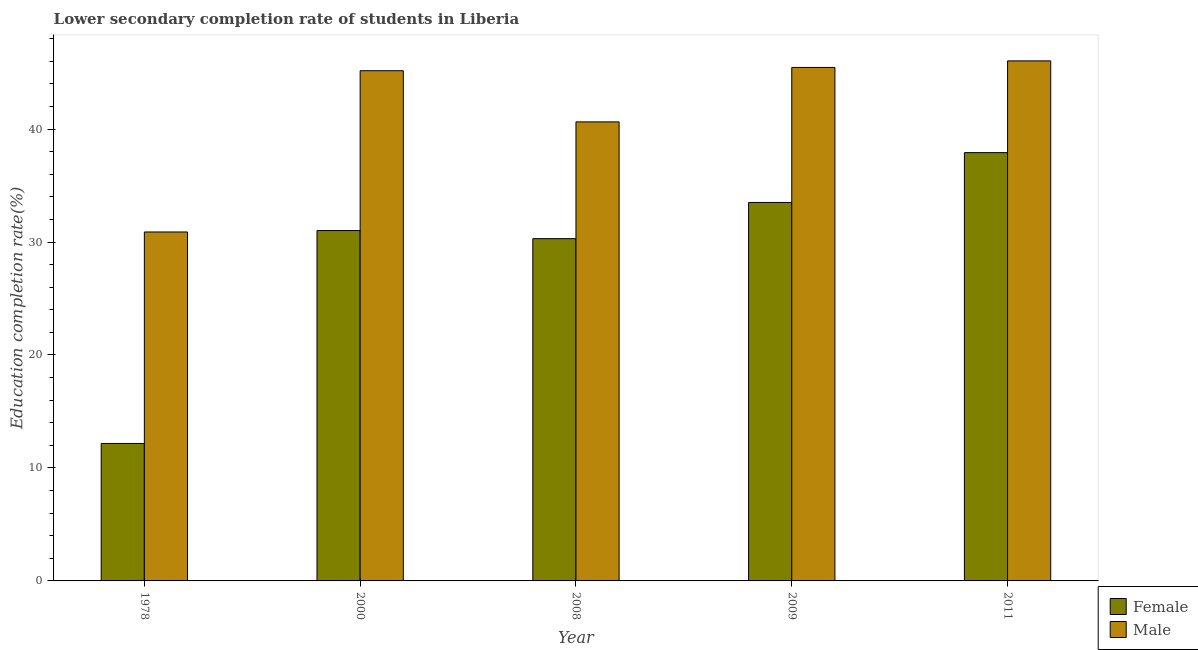How many different coloured bars are there?
Offer a terse response. 2. How many groups of bars are there?
Offer a terse response. 5. Are the number of bars per tick equal to the number of legend labels?
Ensure brevity in your answer.  Yes. How many bars are there on the 3rd tick from the left?
Provide a short and direct response. 2. How many bars are there on the 4th tick from the right?
Your answer should be very brief. 2. What is the label of the 4th group of bars from the left?
Offer a terse response. 2009. In how many cases, is the number of bars for a given year not equal to the number of legend labels?
Your answer should be very brief. 0. What is the education completion rate of male students in 2008?
Keep it short and to the point. 40.64. Across all years, what is the maximum education completion rate of male students?
Your answer should be very brief. 46.04. Across all years, what is the minimum education completion rate of female students?
Make the answer very short. 12.17. In which year was the education completion rate of male students maximum?
Your response must be concise. 2011. In which year was the education completion rate of male students minimum?
Provide a short and direct response. 1978. What is the total education completion rate of male students in the graph?
Give a very brief answer. 208.18. What is the difference between the education completion rate of female students in 2009 and that in 2011?
Ensure brevity in your answer.  -4.41. What is the difference between the education completion rate of female students in 1978 and the education completion rate of male students in 2011?
Provide a short and direct response. -25.75. What is the average education completion rate of male students per year?
Make the answer very short. 41.64. In the year 2011, what is the difference between the education completion rate of female students and education completion rate of male students?
Your answer should be very brief. 0. In how many years, is the education completion rate of female students greater than 8 %?
Your answer should be compact. 5. What is the ratio of the education completion rate of male students in 2009 to that in 2011?
Provide a succinct answer. 0.99. What is the difference between the highest and the second highest education completion rate of male students?
Give a very brief answer. 0.58. What is the difference between the highest and the lowest education completion rate of male students?
Ensure brevity in your answer.  15.15. Is the sum of the education completion rate of female students in 1978 and 2000 greater than the maximum education completion rate of male students across all years?
Provide a short and direct response. Yes. What does the 2nd bar from the left in 1978 represents?
Make the answer very short. Male. What does the 2nd bar from the right in 2008 represents?
Ensure brevity in your answer.  Female. How many bars are there?
Make the answer very short. 10. Does the graph contain any zero values?
Give a very brief answer. No. What is the title of the graph?
Keep it short and to the point. Lower secondary completion rate of students in Liberia. What is the label or title of the X-axis?
Provide a succinct answer. Year. What is the label or title of the Y-axis?
Your response must be concise. Education completion rate(%). What is the Education completion rate(%) in Female in 1978?
Your answer should be very brief. 12.17. What is the Education completion rate(%) in Male in 1978?
Provide a succinct answer. 30.89. What is the Education completion rate(%) in Female in 2000?
Make the answer very short. 31.02. What is the Education completion rate(%) in Male in 2000?
Make the answer very short. 45.16. What is the Education completion rate(%) in Female in 2008?
Give a very brief answer. 30.3. What is the Education completion rate(%) of Male in 2008?
Offer a very short reply. 40.64. What is the Education completion rate(%) in Female in 2009?
Offer a very short reply. 33.5. What is the Education completion rate(%) in Male in 2009?
Provide a succinct answer. 45.45. What is the Education completion rate(%) in Female in 2011?
Your response must be concise. 37.91. What is the Education completion rate(%) of Male in 2011?
Your response must be concise. 46.04. Across all years, what is the maximum Education completion rate(%) of Female?
Your answer should be compact. 37.91. Across all years, what is the maximum Education completion rate(%) in Male?
Make the answer very short. 46.04. Across all years, what is the minimum Education completion rate(%) of Female?
Keep it short and to the point. 12.17. Across all years, what is the minimum Education completion rate(%) of Male?
Your answer should be very brief. 30.89. What is the total Education completion rate(%) of Female in the graph?
Your answer should be compact. 144.9. What is the total Education completion rate(%) of Male in the graph?
Offer a terse response. 208.18. What is the difference between the Education completion rate(%) of Female in 1978 and that in 2000?
Ensure brevity in your answer.  -18.85. What is the difference between the Education completion rate(%) of Male in 1978 and that in 2000?
Your answer should be compact. -14.27. What is the difference between the Education completion rate(%) of Female in 1978 and that in 2008?
Provide a short and direct response. -18.13. What is the difference between the Education completion rate(%) of Male in 1978 and that in 2008?
Your response must be concise. -9.75. What is the difference between the Education completion rate(%) of Female in 1978 and that in 2009?
Provide a short and direct response. -21.33. What is the difference between the Education completion rate(%) in Male in 1978 and that in 2009?
Offer a terse response. -14.56. What is the difference between the Education completion rate(%) in Female in 1978 and that in 2011?
Your answer should be compact. -25.75. What is the difference between the Education completion rate(%) of Male in 1978 and that in 2011?
Keep it short and to the point. -15.15. What is the difference between the Education completion rate(%) of Female in 2000 and that in 2008?
Give a very brief answer. 0.72. What is the difference between the Education completion rate(%) of Male in 2000 and that in 2008?
Provide a succinct answer. 4.53. What is the difference between the Education completion rate(%) of Female in 2000 and that in 2009?
Keep it short and to the point. -2.49. What is the difference between the Education completion rate(%) in Male in 2000 and that in 2009?
Keep it short and to the point. -0.29. What is the difference between the Education completion rate(%) of Female in 2000 and that in 2011?
Your answer should be very brief. -6.9. What is the difference between the Education completion rate(%) in Male in 2000 and that in 2011?
Offer a very short reply. -0.87. What is the difference between the Education completion rate(%) in Female in 2008 and that in 2009?
Ensure brevity in your answer.  -3.2. What is the difference between the Education completion rate(%) in Male in 2008 and that in 2009?
Keep it short and to the point. -4.82. What is the difference between the Education completion rate(%) of Female in 2008 and that in 2011?
Give a very brief answer. -7.61. What is the difference between the Education completion rate(%) of Male in 2008 and that in 2011?
Provide a succinct answer. -5.4. What is the difference between the Education completion rate(%) in Female in 2009 and that in 2011?
Make the answer very short. -4.41. What is the difference between the Education completion rate(%) of Male in 2009 and that in 2011?
Make the answer very short. -0.58. What is the difference between the Education completion rate(%) of Female in 1978 and the Education completion rate(%) of Male in 2000?
Ensure brevity in your answer.  -33. What is the difference between the Education completion rate(%) in Female in 1978 and the Education completion rate(%) in Male in 2008?
Keep it short and to the point. -28.47. What is the difference between the Education completion rate(%) in Female in 1978 and the Education completion rate(%) in Male in 2009?
Your response must be concise. -33.29. What is the difference between the Education completion rate(%) of Female in 1978 and the Education completion rate(%) of Male in 2011?
Make the answer very short. -33.87. What is the difference between the Education completion rate(%) in Female in 2000 and the Education completion rate(%) in Male in 2008?
Ensure brevity in your answer.  -9.62. What is the difference between the Education completion rate(%) in Female in 2000 and the Education completion rate(%) in Male in 2009?
Your answer should be compact. -14.44. What is the difference between the Education completion rate(%) in Female in 2000 and the Education completion rate(%) in Male in 2011?
Provide a succinct answer. -15.02. What is the difference between the Education completion rate(%) of Female in 2008 and the Education completion rate(%) of Male in 2009?
Offer a terse response. -15.15. What is the difference between the Education completion rate(%) in Female in 2008 and the Education completion rate(%) in Male in 2011?
Ensure brevity in your answer.  -15.74. What is the difference between the Education completion rate(%) of Female in 2009 and the Education completion rate(%) of Male in 2011?
Your response must be concise. -12.53. What is the average Education completion rate(%) of Female per year?
Offer a very short reply. 28.98. What is the average Education completion rate(%) of Male per year?
Keep it short and to the point. 41.64. In the year 1978, what is the difference between the Education completion rate(%) in Female and Education completion rate(%) in Male?
Provide a succinct answer. -18.72. In the year 2000, what is the difference between the Education completion rate(%) of Female and Education completion rate(%) of Male?
Ensure brevity in your answer.  -14.15. In the year 2008, what is the difference between the Education completion rate(%) of Female and Education completion rate(%) of Male?
Your response must be concise. -10.34. In the year 2009, what is the difference between the Education completion rate(%) in Female and Education completion rate(%) in Male?
Your answer should be very brief. -11.95. In the year 2011, what is the difference between the Education completion rate(%) in Female and Education completion rate(%) in Male?
Ensure brevity in your answer.  -8.12. What is the ratio of the Education completion rate(%) of Female in 1978 to that in 2000?
Make the answer very short. 0.39. What is the ratio of the Education completion rate(%) of Male in 1978 to that in 2000?
Keep it short and to the point. 0.68. What is the ratio of the Education completion rate(%) of Female in 1978 to that in 2008?
Offer a terse response. 0.4. What is the ratio of the Education completion rate(%) in Male in 1978 to that in 2008?
Provide a short and direct response. 0.76. What is the ratio of the Education completion rate(%) in Female in 1978 to that in 2009?
Your answer should be very brief. 0.36. What is the ratio of the Education completion rate(%) in Male in 1978 to that in 2009?
Give a very brief answer. 0.68. What is the ratio of the Education completion rate(%) of Female in 1978 to that in 2011?
Offer a very short reply. 0.32. What is the ratio of the Education completion rate(%) in Male in 1978 to that in 2011?
Your answer should be very brief. 0.67. What is the ratio of the Education completion rate(%) of Female in 2000 to that in 2008?
Your answer should be compact. 1.02. What is the ratio of the Education completion rate(%) in Male in 2000 to that in 2008?
Provide a short and direct response. 1.11. What is the ratio of the Education completion rate(%) of Female in 2000 to that in 2009?
Offer a very short reply. 0.93. What is the ratio of the Education completion rate(%) in Male in 2000 to that in 2009?
Keep it short and to the point. 0.99. What is the ratio of the Education completion rate(%) of Female in 2000 to that in 2011?
Your answer should be compact. 0.82. What is the ratio of the Education completion rate(%) of Male in 2000 to that in 2011?
Keep it short and to the point. 0.98. What is the ratio of the Education completion rate(%) of Female in 2008 to that in 2009?
Provide a short and direct response. 0.9. What is the ratio of the Education completion rate(%) in Male in 2008 to that in 2009?
Your answer should be very brief. 0.89. What is the ratio of the Education completion rate(%) of Female in 2008 to that in 2011?
Provide a short and direct response. 0.8. What is the ratio of the Education completion rate(%) in Male in 2008 to that in 2011?
Your answer should be compact. 0.88. What is the ratio of the Education completion rate(%) of Female in 2009 to that in 2011?
Provide a short and direct response. 0.88. What is the ratio of the Education completion rate(%) in Male in 2009 to that in 2011?
Provide a succinct answer. 0.99. What is the difference between the highest and the second highest Education completion rate(%) of Female?
Your response must be concise. 4.41. What is the difference between the highest and the second highest Education completion rate(%) in Male?
Your answer should be compact. 0.58. What is the difference between the highest and the lowest Education completion rate(%) of Female?
Offer a terse response. 25.75. What is the difference between the highest and the lowest Education completion rate(%) in Male?
Ensure brevity in your answer.  15.15. 